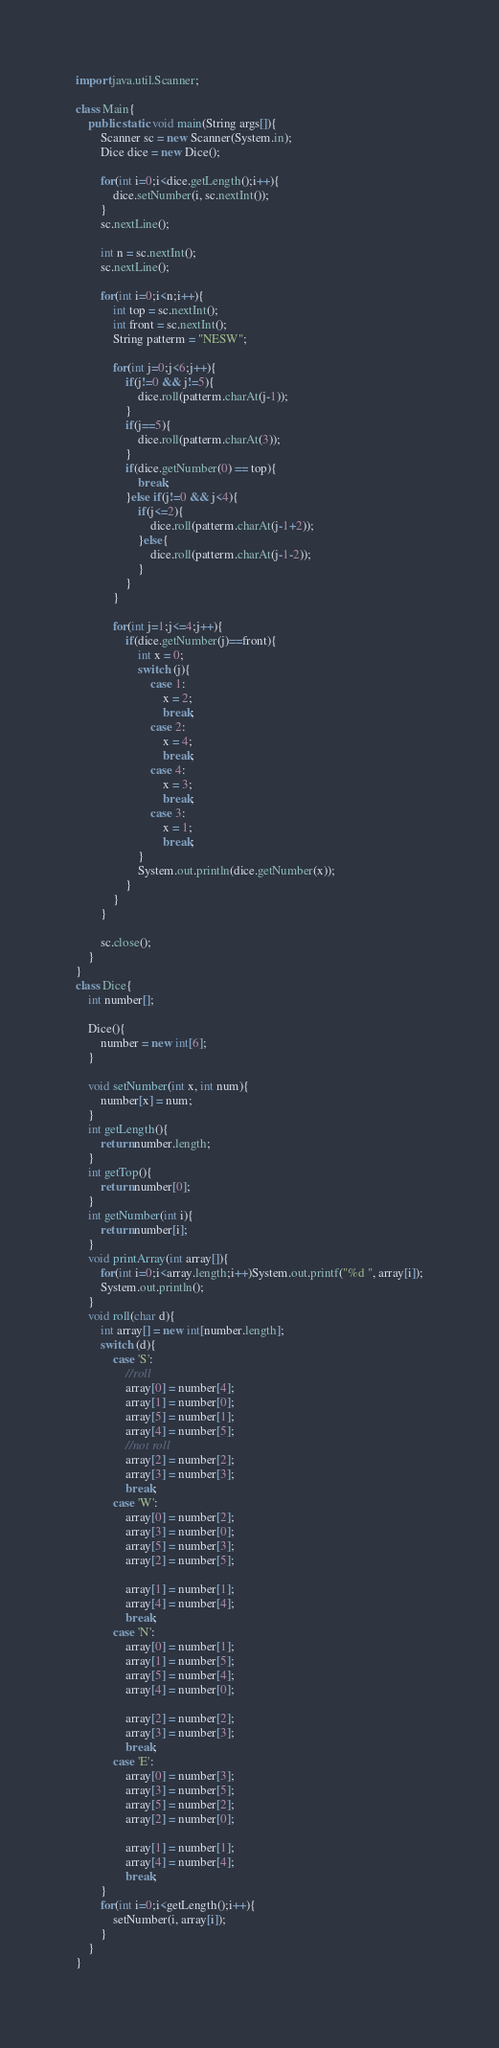<code> <loc_0><loc_0><loc_500><loc_500><_Java_>import java.util.Scanner;

class Main{
    public static void main(String args[]){
        Scanner sc = new Scanner(System.in);
        Dice dice = new Dice();

        for(int i=0;i<dice.getLength();i++){
            dice.setNumber(i, sc.nextInt());
        }
        sc.nextLine();

        int n = sc.nextInt();
        sc.nextLine();

        for(int i=0;i<n;i++){
            int top = sc.nextInt();
            int front = sc.nextInt();
            String patterm = "NESW";

            for(int j=0;j<6;j++){
                if(j!=0 && j!=5){
                    dice.roll(patterm.charAt(j-1));
                }
                if(j==5){
                    dice.roll(patterm.charAt(3));
                }
                if(dice.getNumber(0) == top){
                    break;
                }else if(j!=0 && j<4){
                    if(j<=2){
                        dice.roll(patterm.charAt(j-1+2));
                    }else{
                        dice.roll(patterm.charAt(j-1-2));
                    }
                }
            }
    
            for(int j=1;j<=4;j++){
                if(dice.getNumber(j)==front){
                    int x = 0;
                    switch (j){
                        case 1:
                            x = 2;
                            break;
                        case 2:
                            x = 4;
                            break;
                        case 4:
                            x = 3;
                            break;
                        case 3:
                            x = 1;
                            break;
                    }
                    System.out.println(dice.getNumber(x));
                }
            }
        }

        sc.close();
    }
}
class Dice{
    int number[];

    Dice(){
        number = new int[6];
    }

    void setNumber(int x, int num){
        number[x] = num;
    }
    int getLength(){
        return number.length;
    }
    int getTop(){
        return number[0];
    }
    int getNumber(int i){
        return number[i];        
    }
    void printArray(int array[]){
        for(int i=0;i<array.length;i++)System.out.printf("%d ", array[i]);
        System.out.println();
    }
    void roll(char d){
        int array[] = new int[number.length];
        switch (d){
            case 'S':
                //roll
                array[0] = number[4];
                array[1] = number[0];
                array[5] = number[1];
                array[4] = number[5];
                //not roll
                array[2] = number[2];
                array[3] = number[3];
                break;
            case 'W':
                array[0] = number[2];
                array[3] = number[0];
                array[5] = number[3];
                array[2] = number[5];

                array[1] = number[1];
                array[4] = number[4];
                break;
            case 'N':
                array[0] = number[1];
                array[1] = number[5];
                array[5] = number[4];
                array[4] = number[0];

                array[2] = number[2];
                array[3] = number[3];
                break;
            case 'E':
                array[0] = number[3];
                array[3] = number[5];
                array[5] = number[2];
                array[2] = number[0];
                
                array[1] = number[1];
                array[4] = number[4];
                break;
        }
        for(int i=0;i<getLength();i++){
            setNumber(i, array[i]);
        }
    }
}
</code> 